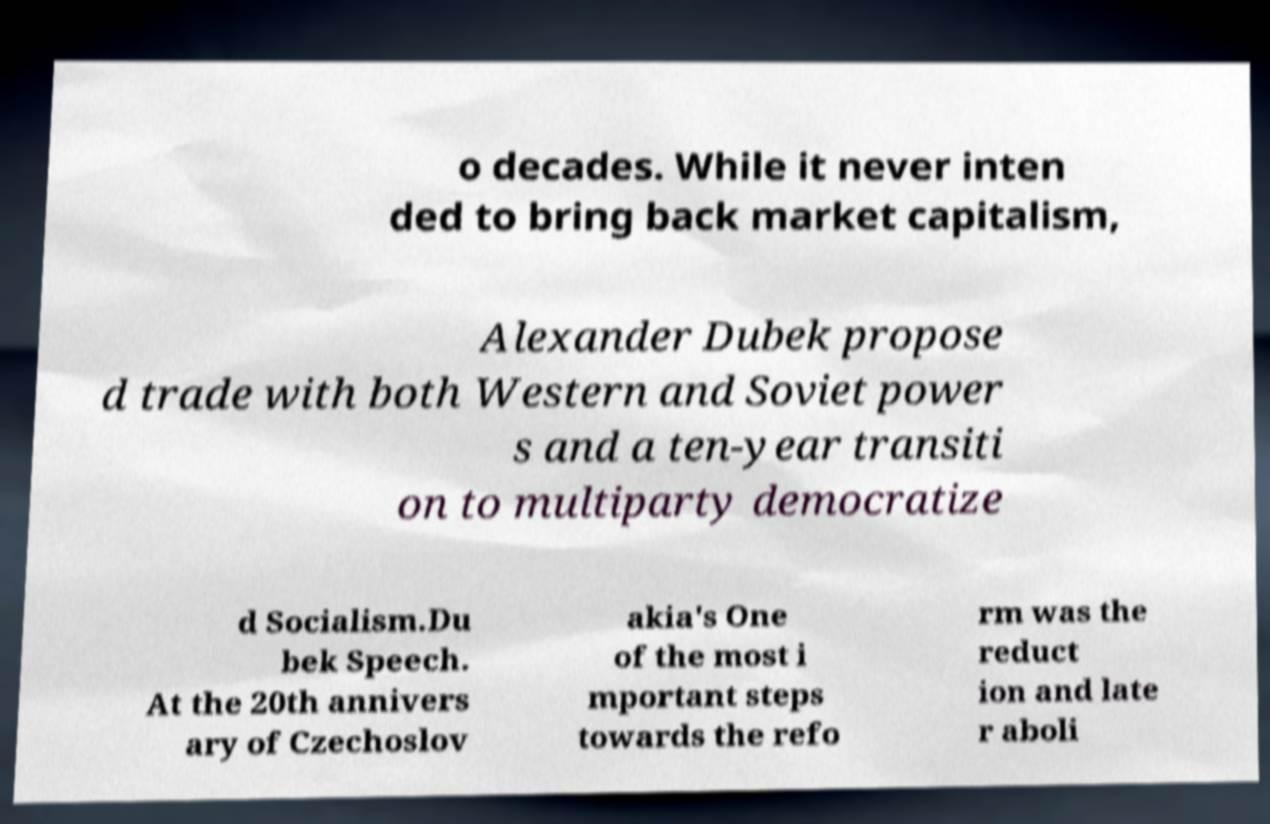Can you accurately transcribe the text from the provided image for me? o decades. While it never inten ded to bring back market capitalism, Alexander Dubek propose d trade with both Western and Soviet power s and a ten-year transiti on to multiparty democratize d Socialism.Du bek Speech. At the 20th annivers ary of Czechoslov akia's One of the most i mportant steps towards the refo rm was the reduct ion and late r aboli 